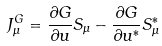Convert formula to latex. <formula><loc_0><loc_0><loc_500><loc_500>J _ { \mu } ^ { G } = \frac { \partial G } { \partial u } S _ { \mu } - \frac { \partial G } { \partial u ^ { * } } S ^ { * } _ { \mu }</formula> 